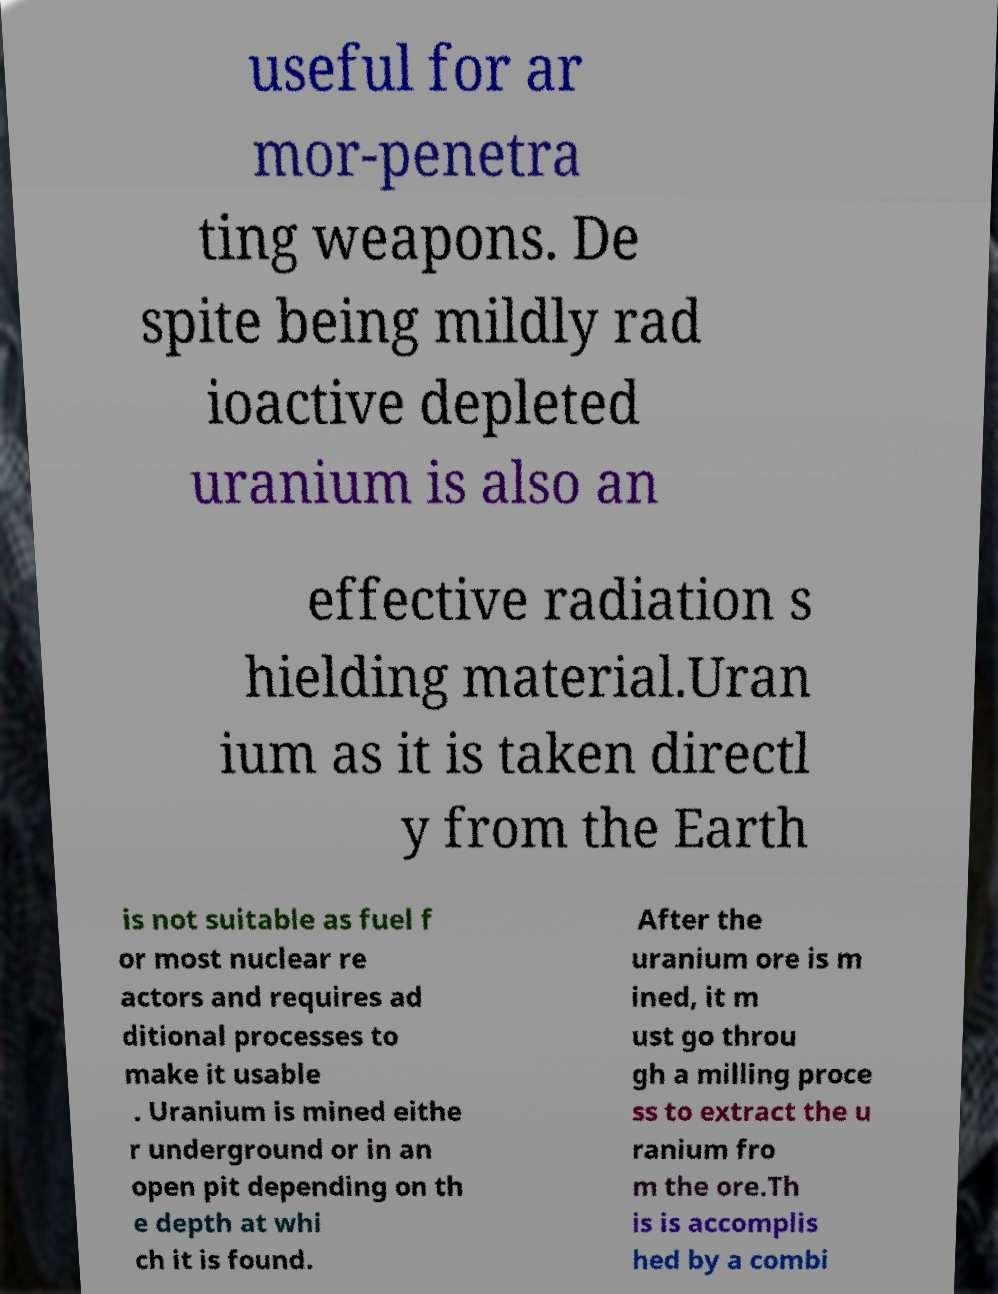Can you read and provide the text displayed in the image?This photo seems to have some interesting text. Can you extract and type it out for me? useful for ar mor-penetra ting weapons. De spite being mildly rad ioactive depleted uranium is also an effective radiation s hielding material.Uran ium as it is taken directl y from the Earth is not suitable as fuel f or most nuclear re actors and requires ad ditional processes to make it usable . Uranium is mined eithe r underground or in an open pit depending on th e depth at whi ch it is found. After the uranium ore is m ined, it m ust go throu gh a milling proce ss to extract the u ranium fro m the ore.Th is is accomplis hed by a combi 